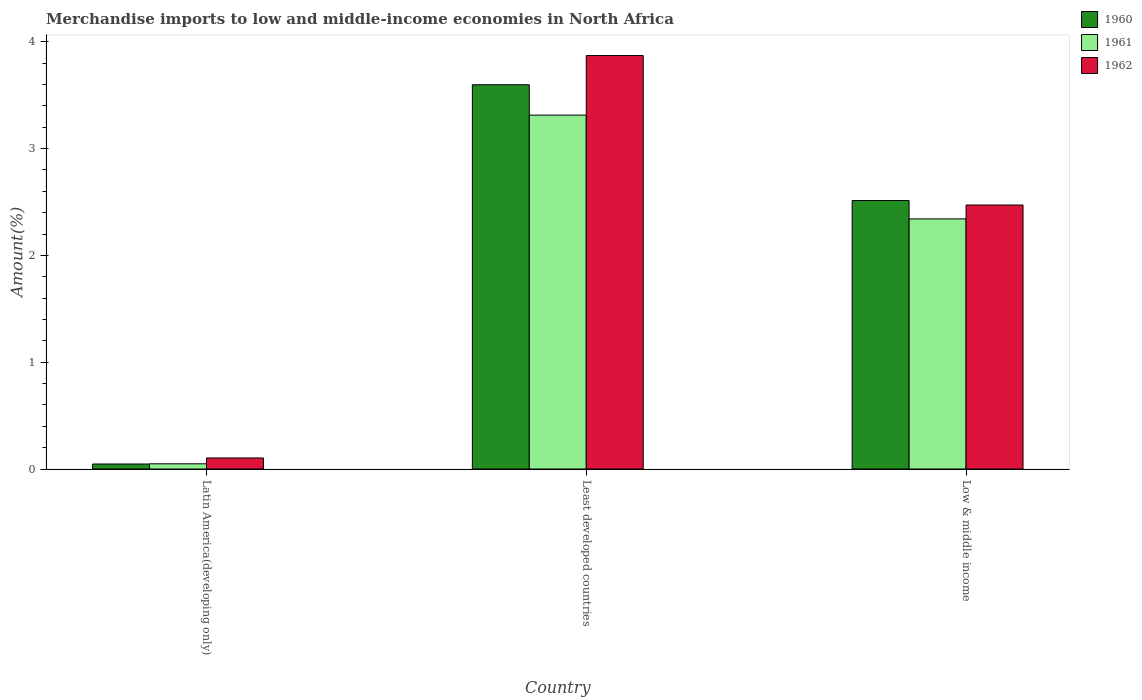How many groups of bars are there?
Your response must be concise. 3. How many bars are there on the 3rd tick from the left?
Provide a short and direct response. 3. What is the label of the 2nd group of bars from the left?
Make the answer very short. Least developed countries. In how many cases, is the number of bars for a given country not equal to the number of legend labels?
Provide a short and direct response. 0. What is the percentage of amount earned from merchandise imports in 1961 in Least developed countries?
Give a very brief answer. 3.31. Across all countries, what is the maximum percentage of amount earned from merchandise imports in 1960?
Offer a terse response. 3.6. Across all countries, what is the minimum percentage of amount earned from merchandise imports in 1962?
Your response must be concise. 0.1. In which country was the percentage of amount earned from merchandise imports in 1960 maximum?
Your answer should be compact. Least developed countries. In which country was the percentage of amount earned from merchandise imports in 1961 minimum?
Your answer should be compact. Latin America(developing only). What is the total percentage of amount earned from merchandise imports in 1962 in the graph?
Provide a short and direct response. 6.45. What is the difference between the percentage of amount earned from merchandise imports in 1961 in Latin America(developing only) and that in Low & middle income?
Your answer should be very brief. -2.29. What is the difference between the percentage of amount earned from merchandise imports in 1960 in Low & middle income and the percentage of amount earned from merchandise imports in 1961 in Latin America(developing only)?
Provide a succinct answer. 2.46. What is the average percentage of amount earned from merchandise imports in 1961 per country?
Offer a terse response. 1.9. What is the difference between the percentage of amount earned from merchandise imports of/in 1960 and percentage of amount earned from merchandise imports of/in 1961 in Latin America(developing only)?
Ensure brevity in your answer.  -0. What is the ratio of the percentage of amount earned from merchandise imports in 1960 in Least developed countries to that in Low & middle income?
Your response must be concise. 1.43. What is the difference between the highest and the second highest percentage of amount earned from merchandise imports in 1960?
Keep it short and to the point. -2.47. What is the difference between the highest and the lowest percentage of amount earned from merchandise imports in 1960?
Make the answer very short. 3.55. In how many countries, is the percentage of amount earned from merchandise imports in 1960 greater than the average percentage of amount earned from merchandise imports in 1960 taken over all countries?
Give a very brief answer. 2. What does the 3rd bar from the right in Least developed countries represents?
Make the answer very short. 1960. Is it the case that in every country, the sum of the percentage of amount earned from merchandise imports in 1961 and percentage of amount earned from merchandise imports in 1960 is greater than the percentage of amount earned from merchandise imports in 1962?
Provide a succinct answer. No. How many bars are there?
Offer a terse response. 9. Are all the bars in the graph horizontal?
Offer a terse response. No. How many countries are there in the graph?
Make the answer very short. 3. What is the difference between two consecutive major ticks on the Y-axis?
Your answer should be compact. 1. Does the graph contain any zero values?
Your response must be concise. No. Does the graph contain grids?
Give a very brief answer. No. How many legend labels are there?
Provide a short and direct response. 3. What is the title of the graph?
Your response must be concise. Merchandise imports to low and middle-income economies in North Africa. Does "1994" appear as one of the legend labels in the graph?
Offer a terse response. No. What is the label or title of the X-axis?
Ensure brevity in your answer.  Country. What is the label or title of the Y-axis?
Offer a very short reply. Amount(%). What is the Amount(%) in 1960 in Latin America(developing only)?
Your answer should be very brief. 0.05. What is the Amount(%) of 1961 in Latin America(developing only)?
Offer a very short reply. 0.05. What is the Amount(%) of 1962 in Latin America(developing only)?
Provide a succinct answer. 0.1. What is the Amount(%) of 1960 in Least developed countries?
Ensure brevity in your answer.  3.6. What is the Amount(%) of 1961 in Least developed countries?
Give a very brief answer. 3.31. What is the Amount(%) in 1962 in Least developed countries?
Your answer should be compact. 3.87. What is the Amount(%) in 1960 in Low & middle income?
Offer a terse response. 2.51. What is the Amount(%) in 1961 in Low & middle income?
Offer a terse response. 2.34. What is the Amount(%) in 1962 in Low & middle income?
Make the answer very short. 2.47. Across all countries, what is the maximum Amount(%) of 1960?
Make the answer very short. 3.6. Across all countries, what is the maximum Amount(%) in 1961?
Offer a terse response. 3.31. Across all countries, what is the maximum Amount(%) of 1962?
Give a very brief answer. 3.87. Across all countries, what is the minimum Amount(%) of 1960?
Provide a succinct answer. 0.05. Across all countries, what is the minimum Amount(%) of 1961?
Keep it short and to the point. 0.05. Across all countries, what is the minimum Amount(%) of 1962?
Your response must be concise. 0.1. What is the total Amount(%) in 1960 in the graph?
Ensure brevity in your answer.  6.16. What is the total Amount(%) of 1961 in the graph?
Offer a terse response. 5.7. What is the total Amount(%) in 1962 in the graph?
Offer a terse response. 6.45. What is the difference between the Amount(%) in 1960 in Latin America(developing only) and that in Least developed countries?
Make the answer very short. -3.55. What is the difference between the Amount(%) in 1961 in Latin America(developing only) and that in Least developed countries?
Offer a terse response. -3.26. What is the difference between the Amount(%) of 1962 in Latin America(developing only) and that in Least developed countries?
Ensure brevity in your answer.  -3.77. What is the difference between the Amount(%) of 1960 in Latin America(developing only) and that in Low & middle income?
Your answer should be compact. -2.47. What is the difference between the Amount(%) in 1961 in Latin America(developing only) and that in Low & middle income?
Provide a succinct answer. -2.29. What is the difference between the Amount(%) in 1962 in Latin America(developing only) and that in Low & middle income?
Your answer should be compact. -2.37. What is the difference between the Amount(%) in 1960 in Least developed countries and that in Low & middle income?
Provide a short and direct response. 1.08. What is the difference between the Amount(%) of 1961 in Least developed countries and that in Low & middle income?
Provide a succinct answer. 0.97. What is the difference between the Amount(%) in 1962 in Least developed countries and that in Low & middle income?
Give a very brief answer. 1.4. What is the difference between the Amount(%) in 1960 in Latin America(developing only) and the Amount(%) in 1961 in Least developed countries?
Make the answer very short. -3.27. What is the difference between the Amount(%) in 1960 in Latin America(developing only) and the Amount(%) in 1962 in Least developed countries?
Provide a succinct answer. -3.82. What is the difference between the Amount(%) of 1961 in Latin America(developing only) and the Amount(%) of 1962 in Least developed countries?
Your answer should be compact. -3.82. What is the difference between the Amount(%) of 1960 in Latin America(developing only) and the Amount(%) of 1961 in Low & middle income?
Make the answer very short. -2.29. What is the difference between the Amount(%) in 1960 in Latin America(developing only) and the Amount(%) in 1962 in Low & middle income?
Your answer should be very brief. -2.43. What is the difference between the Amount(%) in 1961 in Latin America(developing only) and the Amount(%) in 1962 in Low & middle income?
Ensure brevity in your answer.  -2.42. What is the difference between the Amount(%) of 1960 in Least developed countries and the Amount(%) of 1961 in Low & middle income?
Give a very brief answer. 1.26. What is the difference between the Amount(%) in 1960 in Least developed countries and the Amount(%) in 1962 in Low & middle income?
Your response must be concise. 1.13. What is the difference between the Amount(%) in 1961 in Least developed countries and the Amount(%) in 1962 in Low & middle income?
Offer a very short reply. 0.84. What is the average Amount(%) in 1960 per country?
Keep it short and to the point. 2.05. What is the average Amount(%) in 1961 per country?
Your answer should be compact. 1.9. What is the average Amount(%) in 1962 per country?
Ensure brevity in your answer.  2.15. What is the difference between the Amount(%) of 1960 and Amount(%) of 1961 in Latin America(developing only)?
Make the answer very short. -0. What is the difference between the Amount(%) in 1960 and Amount(%) in 1962 in Latin America(developing only)?
Ensure brevity in your answer.  -0.06. What is the difference between the Amount(%) in 1961 and Amount(%) in 1962 in Latin America(developing only)?
Your answer should be compact. -0.05. What is the difference between the Amount(%) of 1960 and Amount(%) of 1961 in Least developed countries?
Keep it short and to the point. 0.28. What is the difference between the Amount(%) of 1960 and Amount(%) of 1962 in Least developed countries?
Your response must be concise. -0.27. What is the difference between the Amount(%) in 1961 and Amount(%) in 1962 in Least developed countries?
Give a very brief answer. -0.56. What is the difference between the Amount(%) of 1960 and Amount(%) of 1961 in Low & middle income?
Offer a terse response. 0.17. What is the difference between the Amount(%) in 1960 and Amount(%) in 1962 in Low & middle income?
Provide a short and direct response. 0.04. What is the difference between the Amount(%) of 1961 and Amount(%) of 1962 in Low & middle income?
Your answer should be very brief. -0.13. What is the ratio of the Amount(%) of 1960 in Latin America(developing only) to that in Least developed countries?
Provide a short and direct response. 0.01. What is the ratio of the Amount(%) of 1961 in Latin America(developing only) to that in Least developed countries?
Offer a very short reply. 0.01. What is the ratio of the Amount(%) in 1962 in Latin America(developing only) to that in Least developed countries?
Provide a succinct answer. 0.03. What is the ratio of the Amount(%) of 1960 in Latin America(developing only) to that in Low & middle income?
Your answer should be compact. 0.02. What is the ratio of the Amount(%) of 1961 in Latin America(developing only) to that in Low & middle income?
Provide a succinct answer. 0.02. What is the ratio of the Amount(%) of 1962 in Latin America(developing only) to that in Low & middle income?
Give a very brief answer. 0.04. What is the ratio of the Amount(%) of 1960 in Least developed countries to that in Low & middle income?
Your answer should be very brief. 1.43. What is the ratio of the Amount(%) of 1961 in Least developed countries to that in Low & middle income?
Offer a terse response. 1.42. What is the ratio of the Amount(%) of 1962 in Least developed countries to that in Low & middle income?
Make the answer very short. 1.57. What is the difference between the highest and the second highest Amount(%) of 1960?
Keep it short and to the point. 1.08. What is the difference between the highest and the second highest Amount(%) in 1961?
Offer a very short reply. 0.97. What is the difference between the highest and the second highest Amount(%) of 1962?
Provide a succinct answer. 1.4. What is the difference between the highest and the lowest Amount(%) of 1960?
Provide a short and direct response. 3.55. What is the difference between the highest and the lowest Amount(%) of 1961?
Ensure brevity in your answer.  3.26. What is the difference between the highest and the lowest Amount(%) of 1962?
Your answer should be compact. 3.77. 